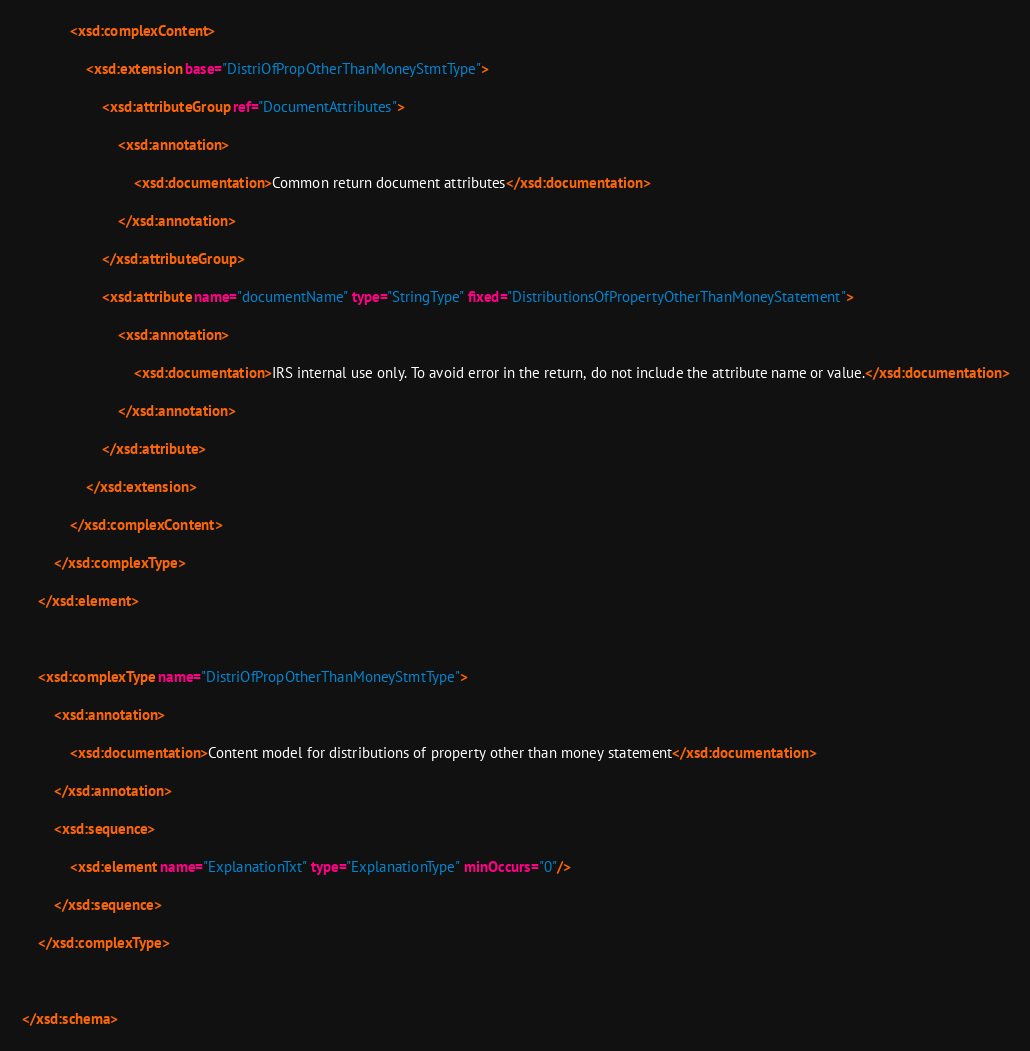Convert code to text. <code><loc_0><loc_0><loc_500><loc_500><_XML_>
			<xsd:complexContent>

				<xsd:extension base="DistriOfPropOtherThanMoneyStmtType">

					<xsd:attributeGroup ref="DocumentAttributes">

						<xsd:annotation>

							<xsd:documentation>Common return document attributes</xsd:documentation>

						</xsd:annotation>

					</xsd:attributeGroup>

					<xsd:attribute name="documentName" type="StringType" fixed="DistributionsOfPropertyOtherThanMoneyStatement">

						<xsd:annotation>

							<xsd:documentation>IRS internal use only. To avoid error in the return, do not include the attribute name or value.</xsd:documentation>

						</xsd:annotation>

					</xsd:attribute>

				</xsd:extension>

			</xsd:complexContent>

		</xsd:complexType>

	</xsd:element>



	<xsd:complexType name="DistriOfPropOtherThanMoneyStmtType">

		<xsd:annotation>

			<xsd:documentation>Content model for distributions of property other than money statement</xsd:documentation>

		</xsd:annotation>

		<xsd:sequence>

			<xsd:element name="ExplanationTxt" type="ExplanationType" minOccurs="0"/>

		</xsd:sequence>

	</xsd:complexType>



</xsd:schema>
</code> 